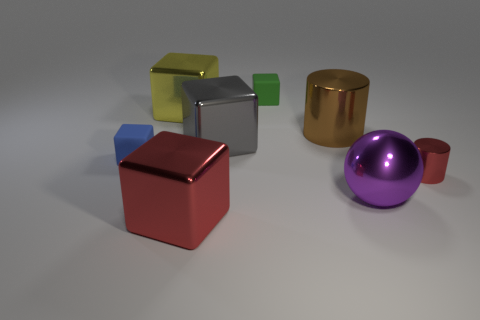How many large metal blocks are the same color as the small cylinder?
Provide a succinct answer. 1. There is a block that is the same color as the small metallic cylinder; what is its material?
Provide a short and direct response. Metal. Is the number of objects in front of the large purple metal ball greater than the number of gray spheres?
Provide a succinct answer. Yes. Do the large brown metal object and the small shiny object have the same shape?
Make the answer very short. Yes. How many large purple balls have the same material as the gray cube?
Provide a succinct answer. 1. What is the size of the yellow shiny object that is the same shape as the gray shiny object?
Offer a terse response. Large. Does the red shiny cylinder have the same size as the blue matte thing?
Give a very brief answer. Yes. There is a red thing on the left side of the red metal thing to the right of the matte thing behind the big gray metal block; what is its shape?
Provide a short and direct response. Cube. There is another shiny thing that is the same shape as the big brown object; what color is it?
Your answer should be compact. Red. There is a block that is in front of the gray metal thing and behind the red cube; what is its size?
Make the answer very short. Small. 